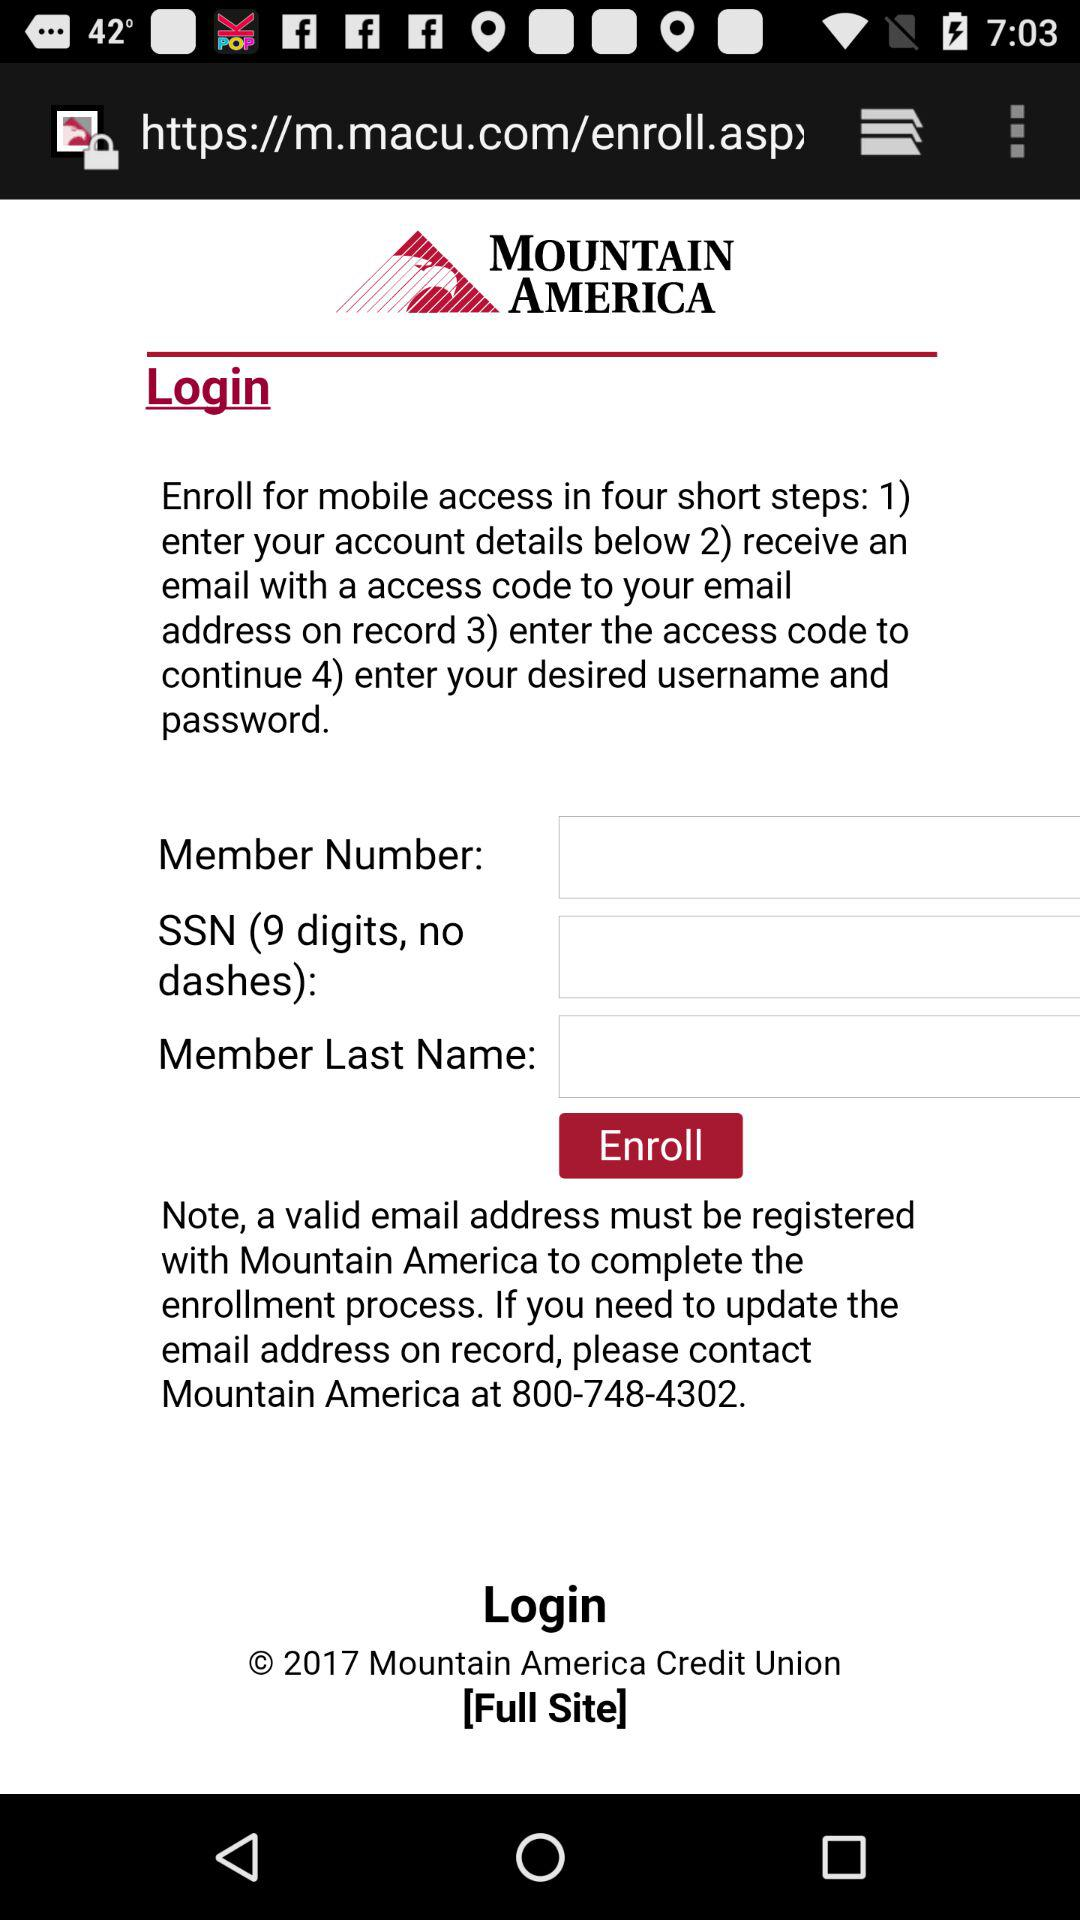What is the member number?
When the provided information is insufficient, respond with <no answer>. <no answer> 